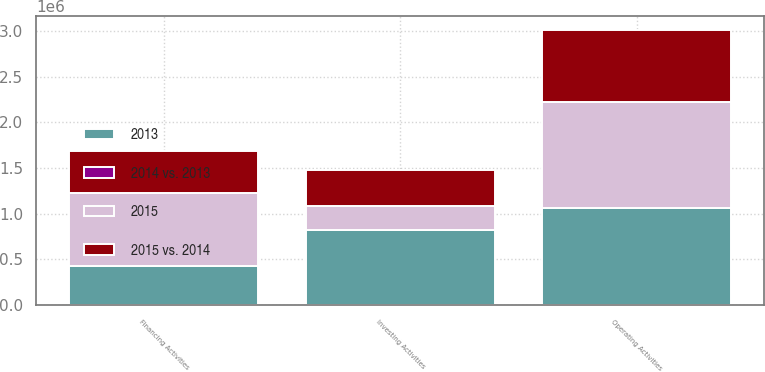Convert chart to OTSL. <chart><loc_0><loc_0><loc_500><loc_500><stacked_bar_chart><ecel><fcel>Operating Activities<fcel>Investing Activities<fcel>Financing Activities<nl><fcel>2015<fcel>1.15937e+06<fcel>263627<fcel>806074<nl><fcel>2015 vs. 2014<fcel>790145<fcel>386715<fcel>455440<nl><fcel>2013<fcel>1.05673e+06<fcel>825579<fcel>425117<nl><fcel>2014 vs. 2013<fcel>47<fcel>32<fcel>77<nl></chart> 